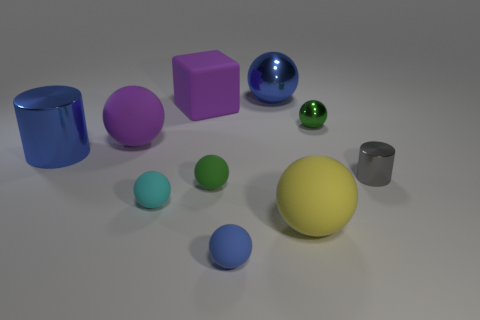What materials do the objects in the image appear to be made from? The objects in the image appear to be made from materials with different reflectivity and textures suggesting some are matte like the yellow sphere, while others, like the blue and green spheres, have a shiny, reflective surface indicative of a polished or rubber material. How many objects are there, and can you describe their shapes? There are ten objects in total. Starting from the left, there's a blue cylinder, a purple cube, a blue sphere, a large yellow sphere, three smaller spheres in green, teal, and light blue, a pink cube, a small green sphere, and a gray cylinder. 